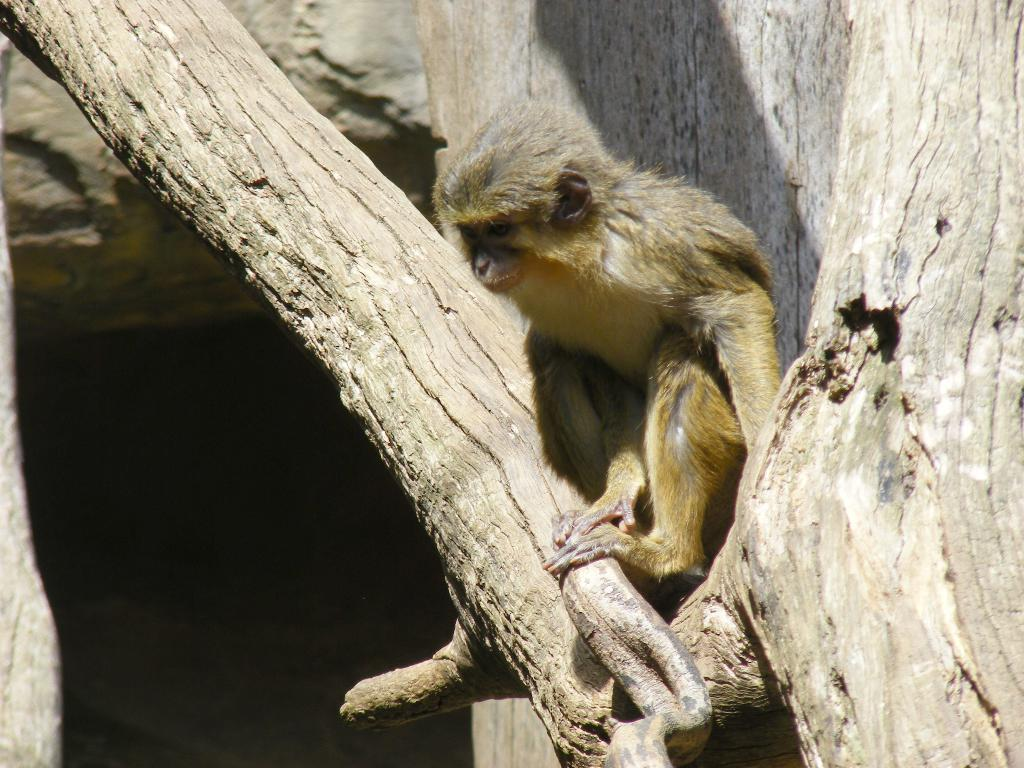What animal is present in the image? There is a monkey in the picture. Where is the monkey located? The monkey is on a tree. What is the color of the monkey? The monkey is brown in color. What type of bushes can be seen surrounding the monkey in the image? There is no mention of bushes in the provided facts, so we cannot determine if bushes are present in the image. 